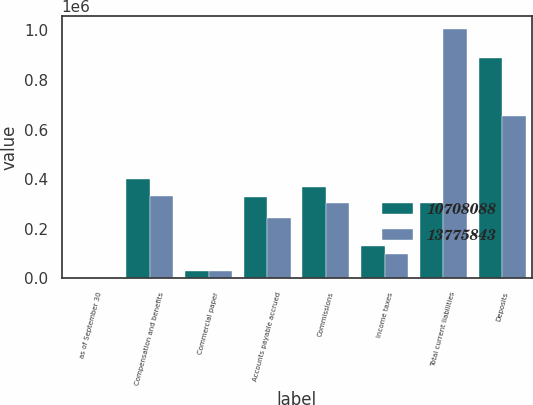<chart> <loc_0><loc_0><loc_500><loc_500><stacked_bar_chart><ecel><fcel>as of September 30<fcel>Compensation and benefits<fcel>Commercial paper<fcel>Accounts payable accrued<fcel>Commissions<fcel>Income taxes<fcel>Total current liabilities<fcel>Deposits<nl><fcel>1.07081e+07<fcel>2011<fcel>400885<fcel>29997<fcel>328303<fcel>369539<fcel>128826<fcel>302366<fcel>890189<nl><fcel>1.37758e+07<fcel>2010<fcel>330879<fcel>29997<fcel>244203<fcel>302366<fcel>99197<fcel>1.00664e+06<fcel>655748<nl></chart> 